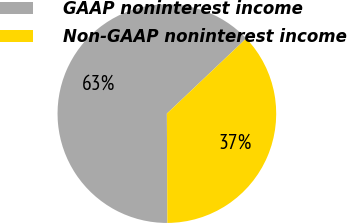Convert chart. <chart><loc_0><loc_0><loc_500><loc_500><pie_chart><fcel>GAAP noninterest income<fcel>Non-GAAP noninterest income<nl><fcel>63.01%<fcel>36.99%<nl></chart> 